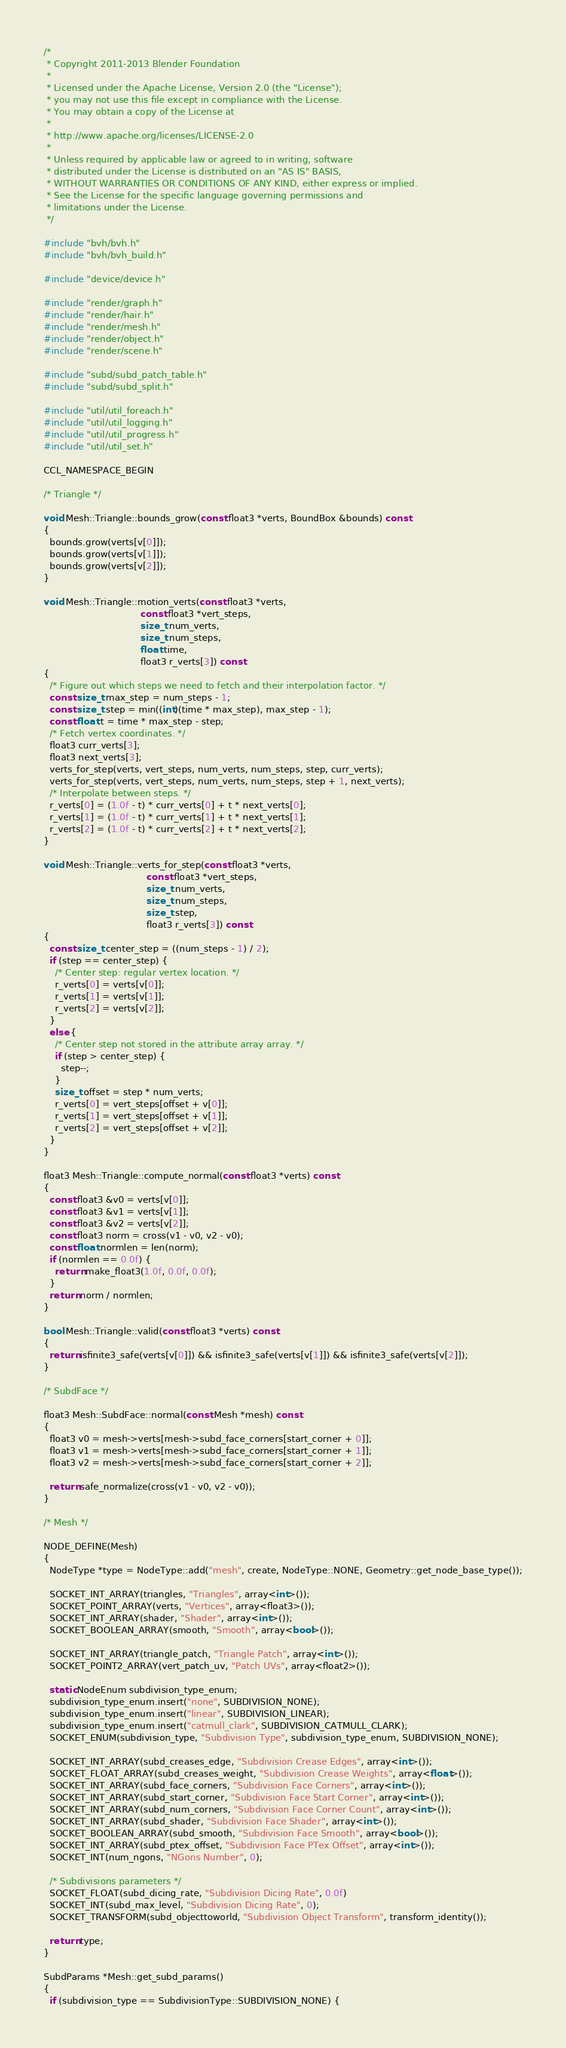Convert code to text. <code><loc_0><loc_0><loc_500><loc_500><_C++_>/*
 * Copyright 2011-2013 Blender Foundation
 *
 * Licensed under the Apache License, Version 2.0 (the "License");
 * you may not use this file except in compliance with the License.
 * You may obtain a copy of the License at
 *
 * http://www.apache.org/licenses/LICENSE-2.0
 *
 * Unless required by applicable law or agreed to in writing, software
 * distributed under the License is distributed on an "AS IS" BASIS,
 * WITHOUT WARRANTIES OR CONDITIONS OF ANY KIND, either express or implied.
 * See the License for the specific language governing permissions and
 * limitations under the License.
 */

#include "bvh/bvh.h"
#include "bvh/bvh_build.h"

#include "device/device.h"

#include "render/graph.h"
#include "render/hair.h"
#include "render/mesh.h"
#include "render/object.h"
#include "render/scene.h"

#include "subd/subd_patch_table.h"
#include "subd/subd_split.h"

#include "util/util_foreach.h"
#include "util/util_logging.h"
#include "util/util_progress.h"
#include "util/util_set.h"

CCL_NAMESPACE_BEGIN

/* Triangle */

void Mesh::Triangle::bounds_grow(const float3 *verts, BoundBox &bounds) const
{
  bounds.grow(verts[v[0]]);
  bounds.grow(verts[v[1]]);
  bounds.grow(verts[v[2]]);
}

void Mesh::Triangle::motion_verts(const float3 *verts,
                                  const float3 *vert_steps,
                                  size_t num_verts,
                                  size_t num_steps,
                                  float time,
                                  float3 r_verts[3]) const
{
  /* Figure out which steps we need to fetch and their interpolation factor. */
  const size_t max_step = num_steps - 1;
  const size_t step = min((int)(time * max_step), max_step - 1);
  const float t = time * max_step - step;
  /* Fetch vertex coordinates. */
  float3 curr_verts[3];
  float3 next_verts[3];
  verts_for_step(verts, vert_steps, num_verts, num_steps, step, curr_verts);
  verts_for_step(verts, vert_steps, num_verts, num_steps, step + 1, next_verts);
  /* Interpolate between steps. */
  r_verts[0] = (1.0f - t) * curr_verts[0] + t * next_verts[0];
  r_verts[1] = (1.0f - t) * curr_verts[1] + t * next_verts[1];
  r_verts[2] = (1.0f - t) * curr_verts[2] + t * next_verts[2];
}

void Mesh::Triangle::verts_for_step(const float3 *verts,
                                    const float3 *vert_steps,
                                    size_t num_verts,
                                    size_t num_steps,
                                    size_t step,
                                    float3 r_verts[3]) const
{
  const size_t center_step = ((num_steps - 1) / 2);
  if (step == center_step) {
    /* Center step: regular vertex location. */
    r_verts[0] = verts[v[0]];
    r_verts[1] = verts[v[1]];
    r_verts[2] = verts[v[2]];
  }
  else {
    /* Center step not stored in the attribute array array. */
    if (step > center_step) {
      step--;
    }
    size_t offset = step * num_verts;
    r_verts[0] = vert_steps[offset + v[0]];
    r_verts[1] = vert_steps[offset + v[1]];
    r_verts[2] = vert_steps[offset + v[2]];
  }
}

float3 Mesh::Triangle::compute_normal(const float3 *verts) const
{
  const float3 &v0 = verts[v[0]];
  const float3 &v1 = verts[v[1]];
  const float3 &v2 = verts[v[2]];
  const float3 norm = cross(v1 - v0, v2 - v0);
  const float normlen = len(norm);
  if (normlen == 0.0f) {
    return make_float3(1.0f, 0.0f, 0.0f);
  }
  return norm / normlen;
}

bool Mesh::Triangle::valid(const float3 *verts) const
{
  return isfinite3_safe(verts[v[0]]) && isfinite3_safe(verts[v[1]]) && isfinite3_safe(verts[v[2]]);
}

/* SubdFace */

float3 Mesh::SubdFace::normal(const Mesh *mesh) const
{
  float3 v0 = mesh->verts[mesh->subd_face_corners[start_corner + 0]];
  float3 v1 = mesh->verts[mesh->subd_face_corners[start_corner + 1]];
  float3 v2 = mesh->verts[mesh->subd_face_corners[start_corner + 2]];

  return safe_normalize(cross(v1 - v0, v2 - v0));
}

/* Mesh */

NODE_DEFINE(Mesh)
{
  NodeType *type = NodeType::add("mesh", create, NodeType::NONE, Geometry::get_node_base_type());

  SOCKET_INT_ARRAY(triangles, "Triangles", array<int>());
  SOCKET_POINT_ARRAY(verts, "Vertices", array<float3>());
  SOCKET_INT_ARRAY(shader, "Shader", array<int>());
  SOCKET_BOOLEAN_ARRAY(smooth, "Smooth", array<bool>());

  SOCKET_INT_ARRAY(triangle_patch, "Triangle Patch", array<int>());
  SOCKET_POINT2_ARRAY(vert_patch_uv, "Patch UVs", array<float2>());

  static NodeEnum subdivision_type_enum;
  subdivision_type_enum.insert("none", SUBDIVISION_NONE);
  subdivision_type_enum.insert("linear", SUBDIVISION_LINEAR);
  subdivision_type_enum.insert("catmull_clark", SUBDIVISION_CATMULL_CLARK);
  SOCKET_ENUM(subdivision_type, "Subdivision Type", subdivision_type_enum, SUBDIVISION_NONE);

  SOCKET_INT_ARRAY(subd_creases_edge, "Subdivision Crease Edges", array<int>());
  SOCKET_FLOAT_ARRAY(subd_creases_weight, "Subdivision Crease Weights", array<float>());
  SOCKET_INT_ARRAY(subd_face_corners, "Subdivision Face Corners", array<int>());
  SOCKET_INT_ARRAY(subd_start_corner, "Subdivision Face Start Corner", array<int>());
  SOCKET_INT_ARRAY(subd_num_corners, "Subdivision Face Corner Count", array<int>());
  SOCKET_INT_ARRAY(subd_shader, "Subdivision Face Shader", array<int>());
  SOCKET_BOOLEAN_ARRAY(subd_smooth, "Subdivision Face Smooth", array<bool>());
  SOCKET_INT_ARRAY(subd_ptex_offset, "Subdivision Face PTex Offset", array<int>());
  SOCKET_INT(num_ngons, "NGons Number", 0);

  /* Subdivisions parameters */
  SOCKET_FLOAT(subd_dicing_rate, "Subdivision Dicing Rate", 0.0f)
  SOCKET_INT(subd_max_level, "Subdivision Dicing Rate", 0);
  SOCKET_TRANSFORM(subd_objecttoworld, "Subdivision Object Transform", transform_identity());

  return type;
}

SubdParams *Mesh::get_subd_params()
{
  if (subdivision_type == SubdivisionType::SUBDIVISION_NONE) {</code> 